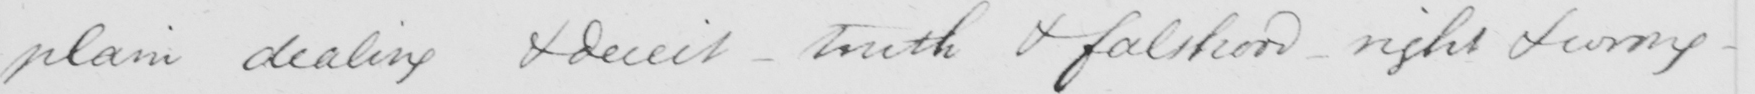Please provide the text content of this handwritten line. plain dealing & deceit - truth & falsehood - right & wrong - 